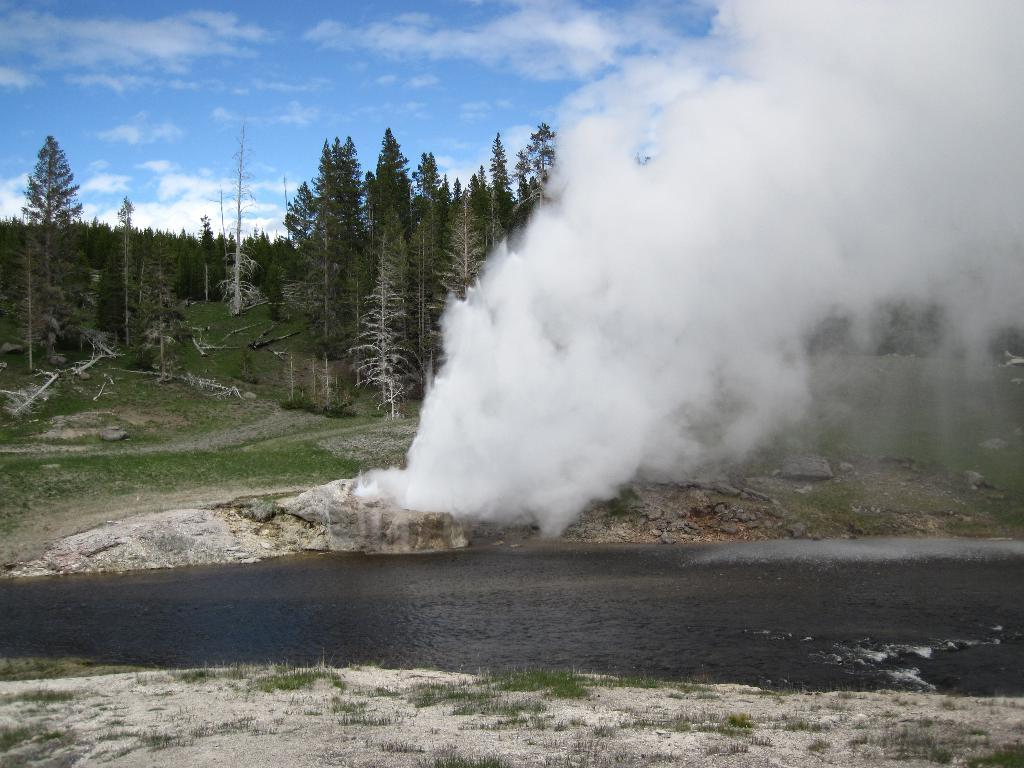What body of water is present in the image? There is a lake in the image. How does the lake appear in the image? The lake appears to be flowing. What type of vegetation is present on the land? There is grass on the land. What is the color of the smoke visible in the image? White color smoke is visible. What can be seen in the background of the image? There are trees and the sky in the background of the image. What is the condition of the sky in the image? The sky is visible in the background of the image, and there are clouds present. What vein is visible in the image? There are no veins visible in the image; it features a flowing lake, grass, smoke, trees, and a sky with clouds. What sense is being stimulated by the image? The image is visual, so it primarily stimulates the sense of sight. 